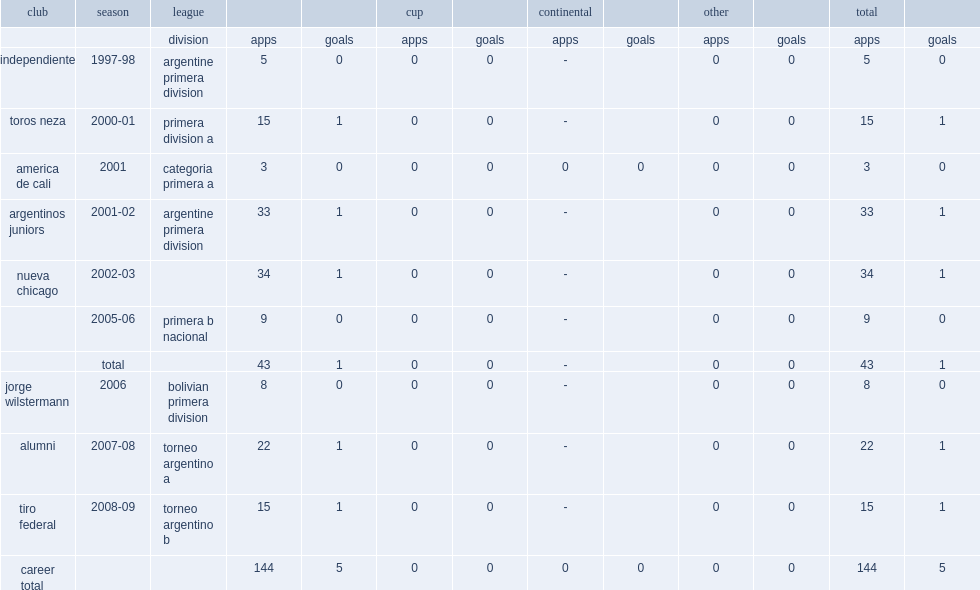Which league did garcia play side jorge wilstermann in 2006? Bolivian primera division. 